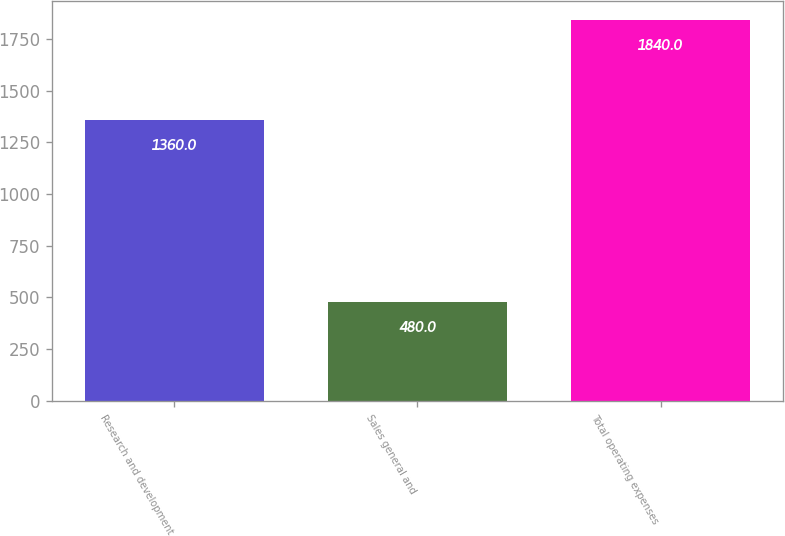Convert chart to OTSL. <chart><loc_0><loc_0><loc_500><loc_500><bar_chart><fcel>Research and development<fcel>Sales general and<fcel>Total operating expenses<nl><fcel>1360<fcel>480<fcel>1840<nl></chart> 